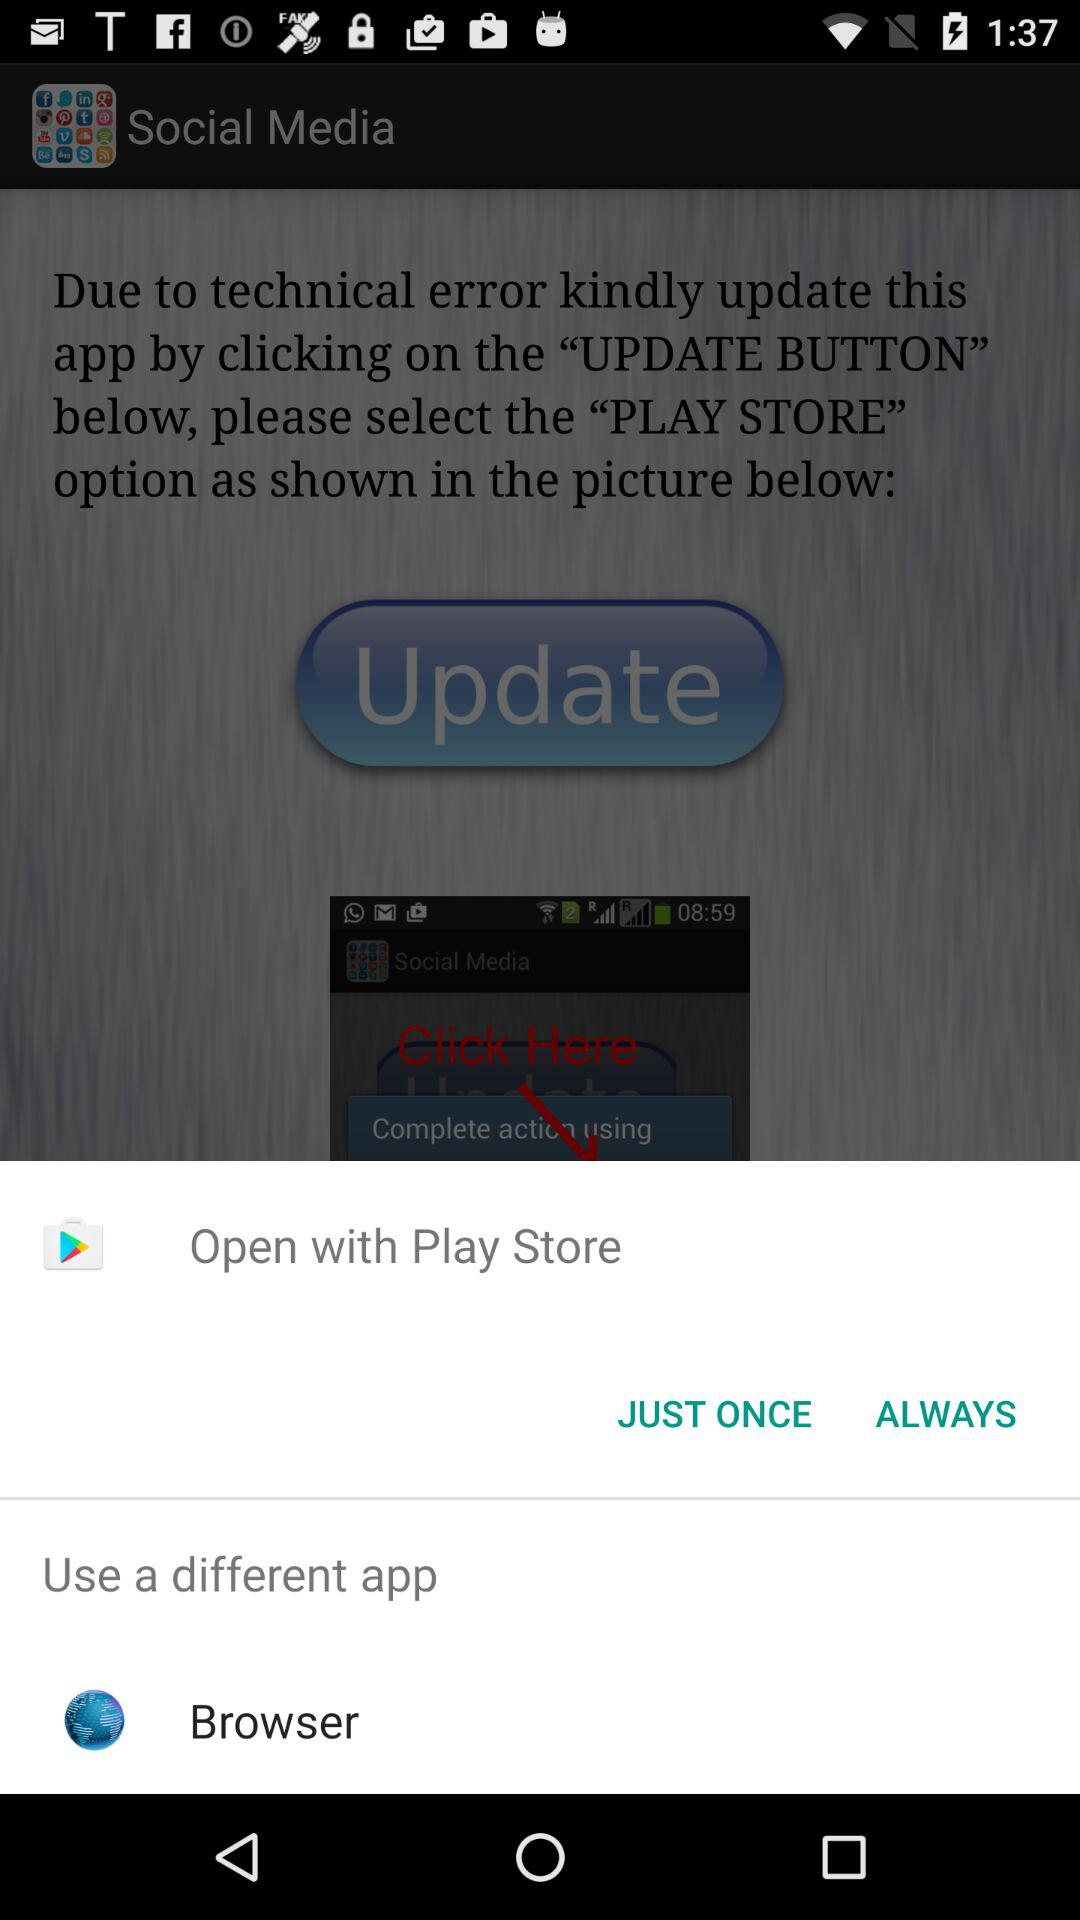Through which app can we open the browser? You can open the browser through the "Play Store". 